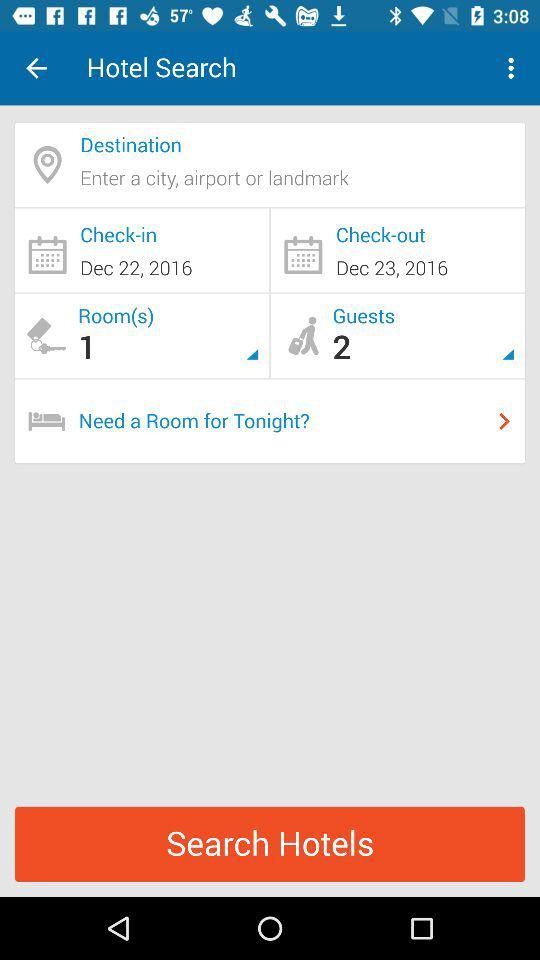How many rooms are selected? There is 1 room selected. 